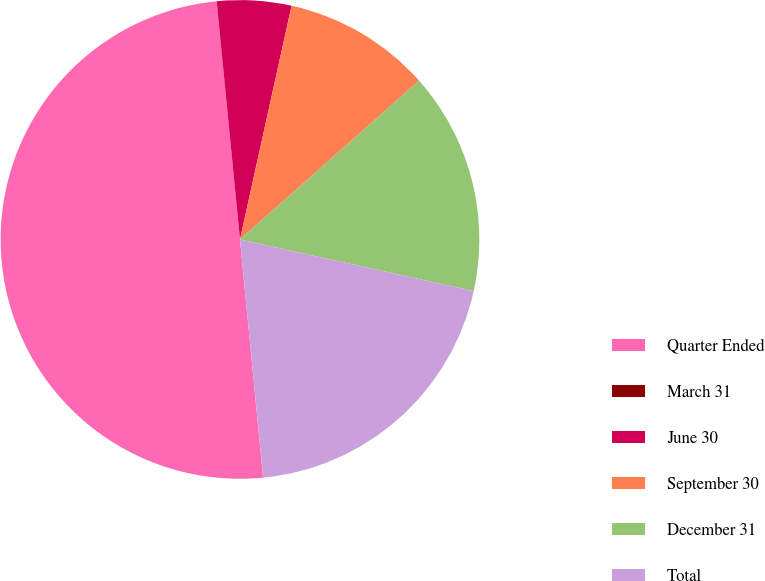Convert chart to OTSL. <chart><loc_0><loc_0><loc_500><loc_500><pie_chart><fcel>Quarter Ended<fcel>March 31<fcel>June 30<fcel>September 30<fcel>December 31<fcel>Total<nl><fcel>49.98%<fcel>0.01%<fcel>5.01%<fcel>10.0%<fcel>15.0%<fcel>20.0%<nl></chart> 